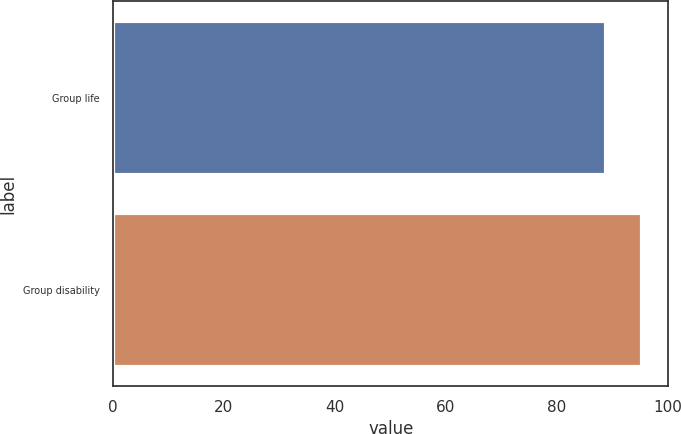Convert chart to OTSL. <chart><loc_0><loc_0><loc_500><loc_500><bar_chart><fcel>Group life<fcel>Group disability<nl><fcel>88.9<fcel>95.4<nl></chart> 